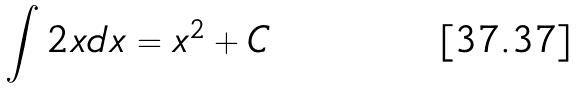<formula> <loc_0><loc_0><loc_500><loc_500>\int 2 x d x = x ^ { 2 } + C</formula> 